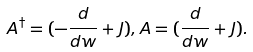<formula> <loc_0><loc_0><loc_500><loc_500>A ^ { \dagger } = ( - \frac { d } { d w } + J ) , A = ( \frac { d } { d w } + J ) .</formula> 